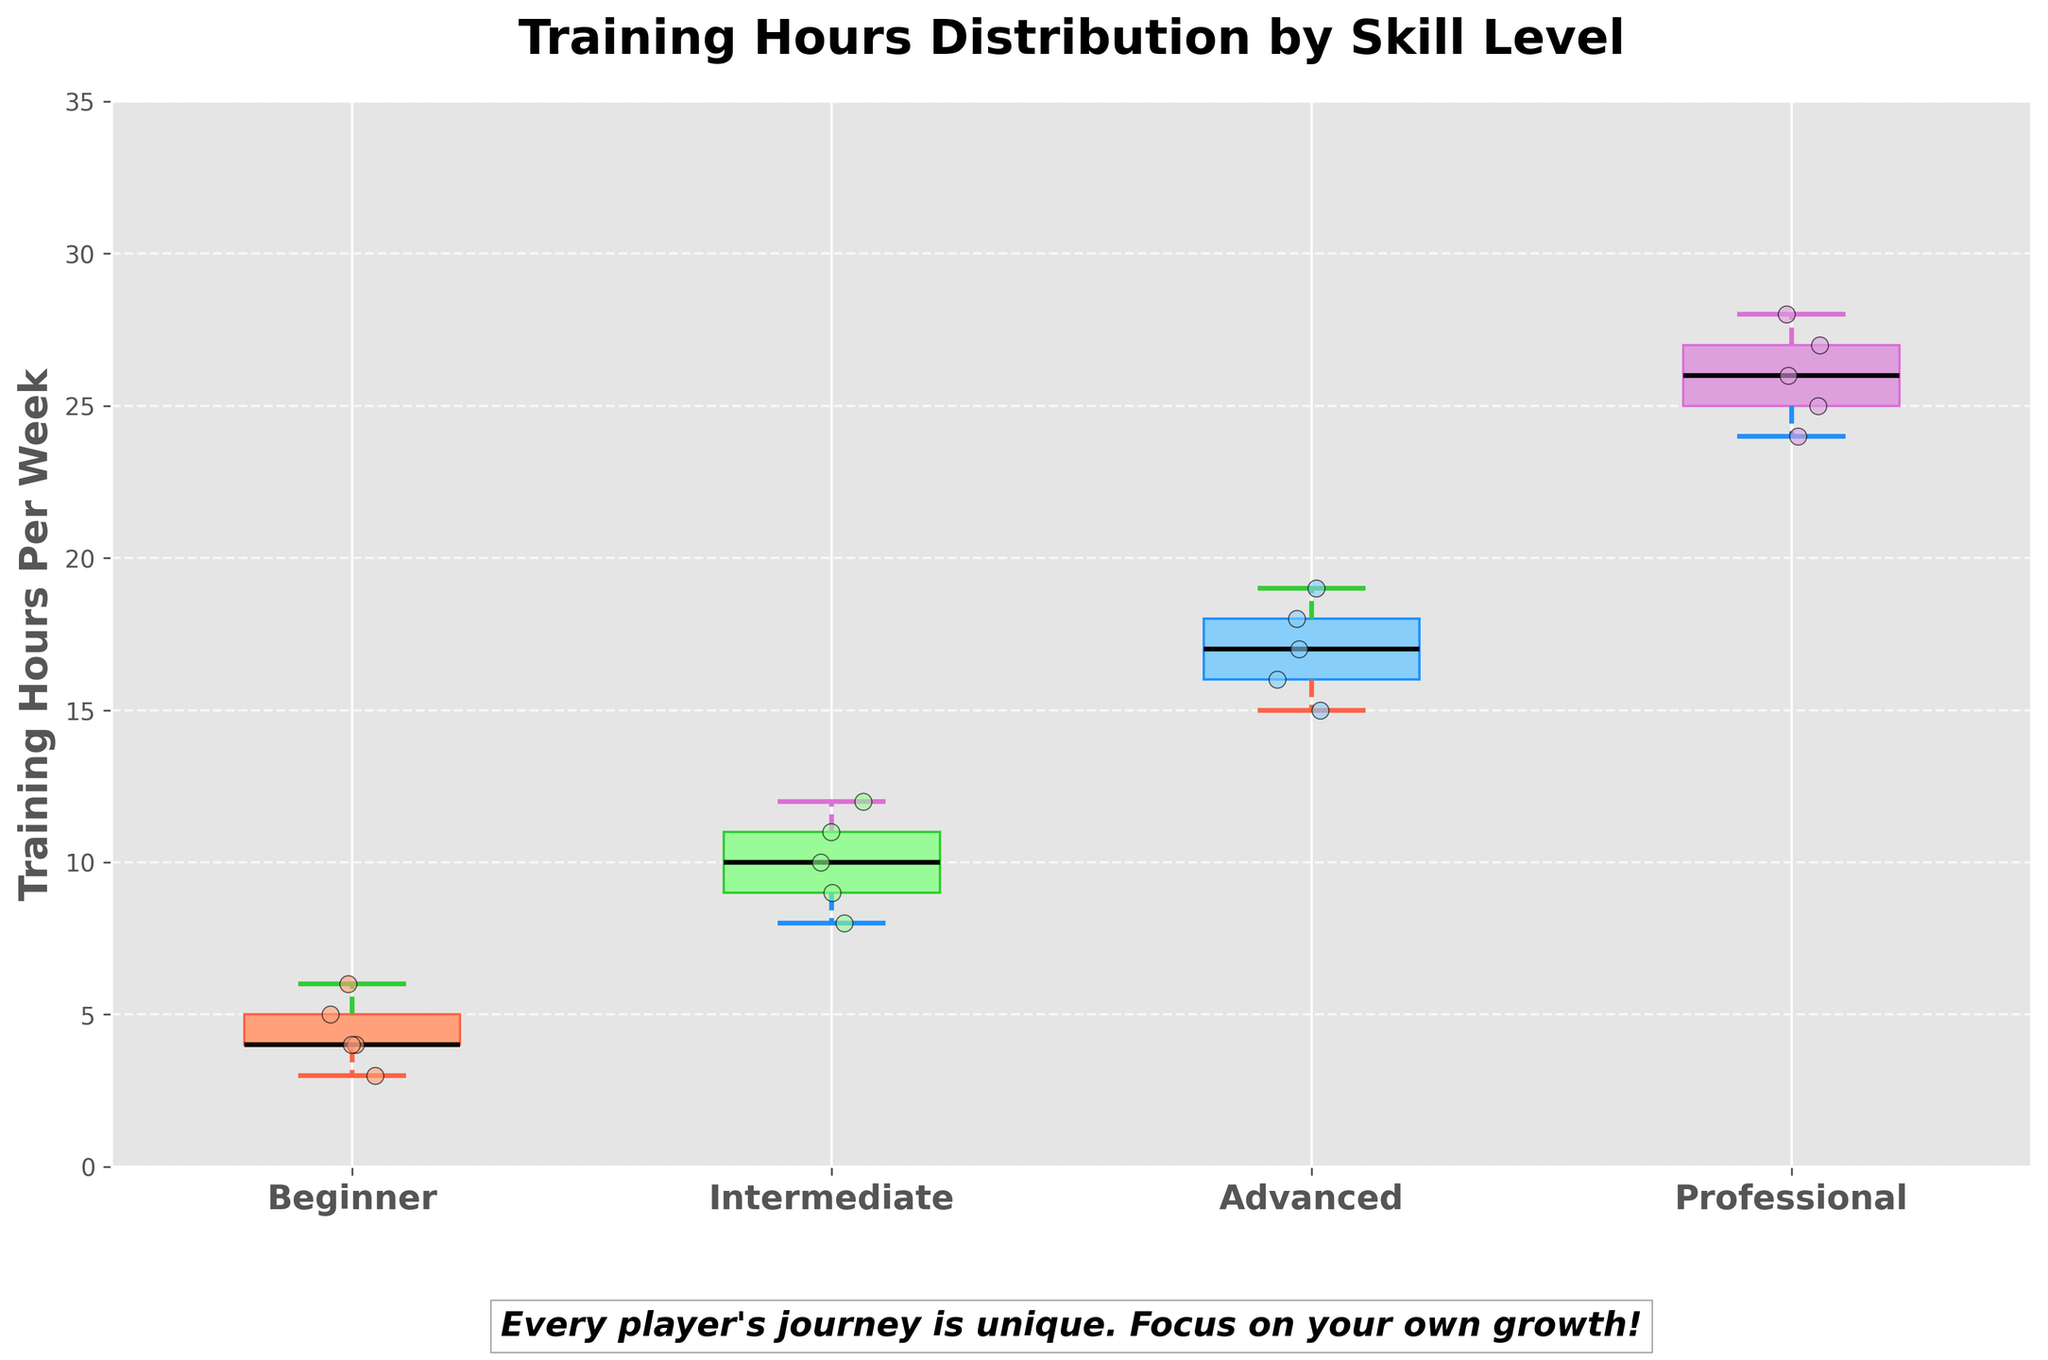What is the title of the figure? The title of the figure is generally placed at the top of the plot. In this case, the title can be visually observed as "Training Hours Distribution by Skill Level".
Answer: Training Hours Distribution by Skill Level Which skill level has the highest median training hours per week? Typically, the median in a box plot is indicated by the line inside the box. By comparing the lines, the Professional group has the highest median training hours.
Answer: Professional How many skill levels are displayed in the figure? The x-axis labels indicate the distinct skill levels. By counting these labels, we have Beginner, Intermediate, Advanced, and Professional.
Answer: 4 In which skill level is the interquartile range (IQR) the largest? The IQR is represented by the height of the box in a box plot. By comparing the heights of the boxes, the Professional skill level has the largest IQR.
Answer: Professional What is the range of training hours for the Advanced skill level? The range in a box plot is given by the difference between the maximum and minimum whiskers. For the Advanced skill level, the minimum is 15 and the maximum is 19, hence the range is 19 - 15.
Answer: 4 Which skill level has the most consistent training hours? Consistency is indicated by a smaller spread of training hours, which can be judged by the size of the box and the reach of the whiskers. The Beginner group has the smallest spread, indicating the most consistency.
Answer: Beginner What's the difference between the median training hours of Intermediate and Advanced skill levels? The median is shown by the line in the middle of each box. For Intermediate, it is around 10.5, and for Advanced, it is around 17. Therefore, the difference is 17 - 10.5.
Answer: 6.5 Which skill level has the widest range of training hours? The range is seen by the total span of the whiskers. By comparing the whisker lengths, the Professional skill level has the widest range, from 24 to 28.
Answer: Professional For which skill level are the whiskers closest to each other? Whiskers indicate the range of the data within each skill level. By comparing the distances between the whiskers, the Beginner level shows the closest whiskers.
Answer: Beginner What does the text at the bottom of the plot encourage players to focus on? The text at the bottom of the plot is a motivational message and reads, "Every player's journey is unique. Focus on your own growth!"
Answer: Focus on your own growth 